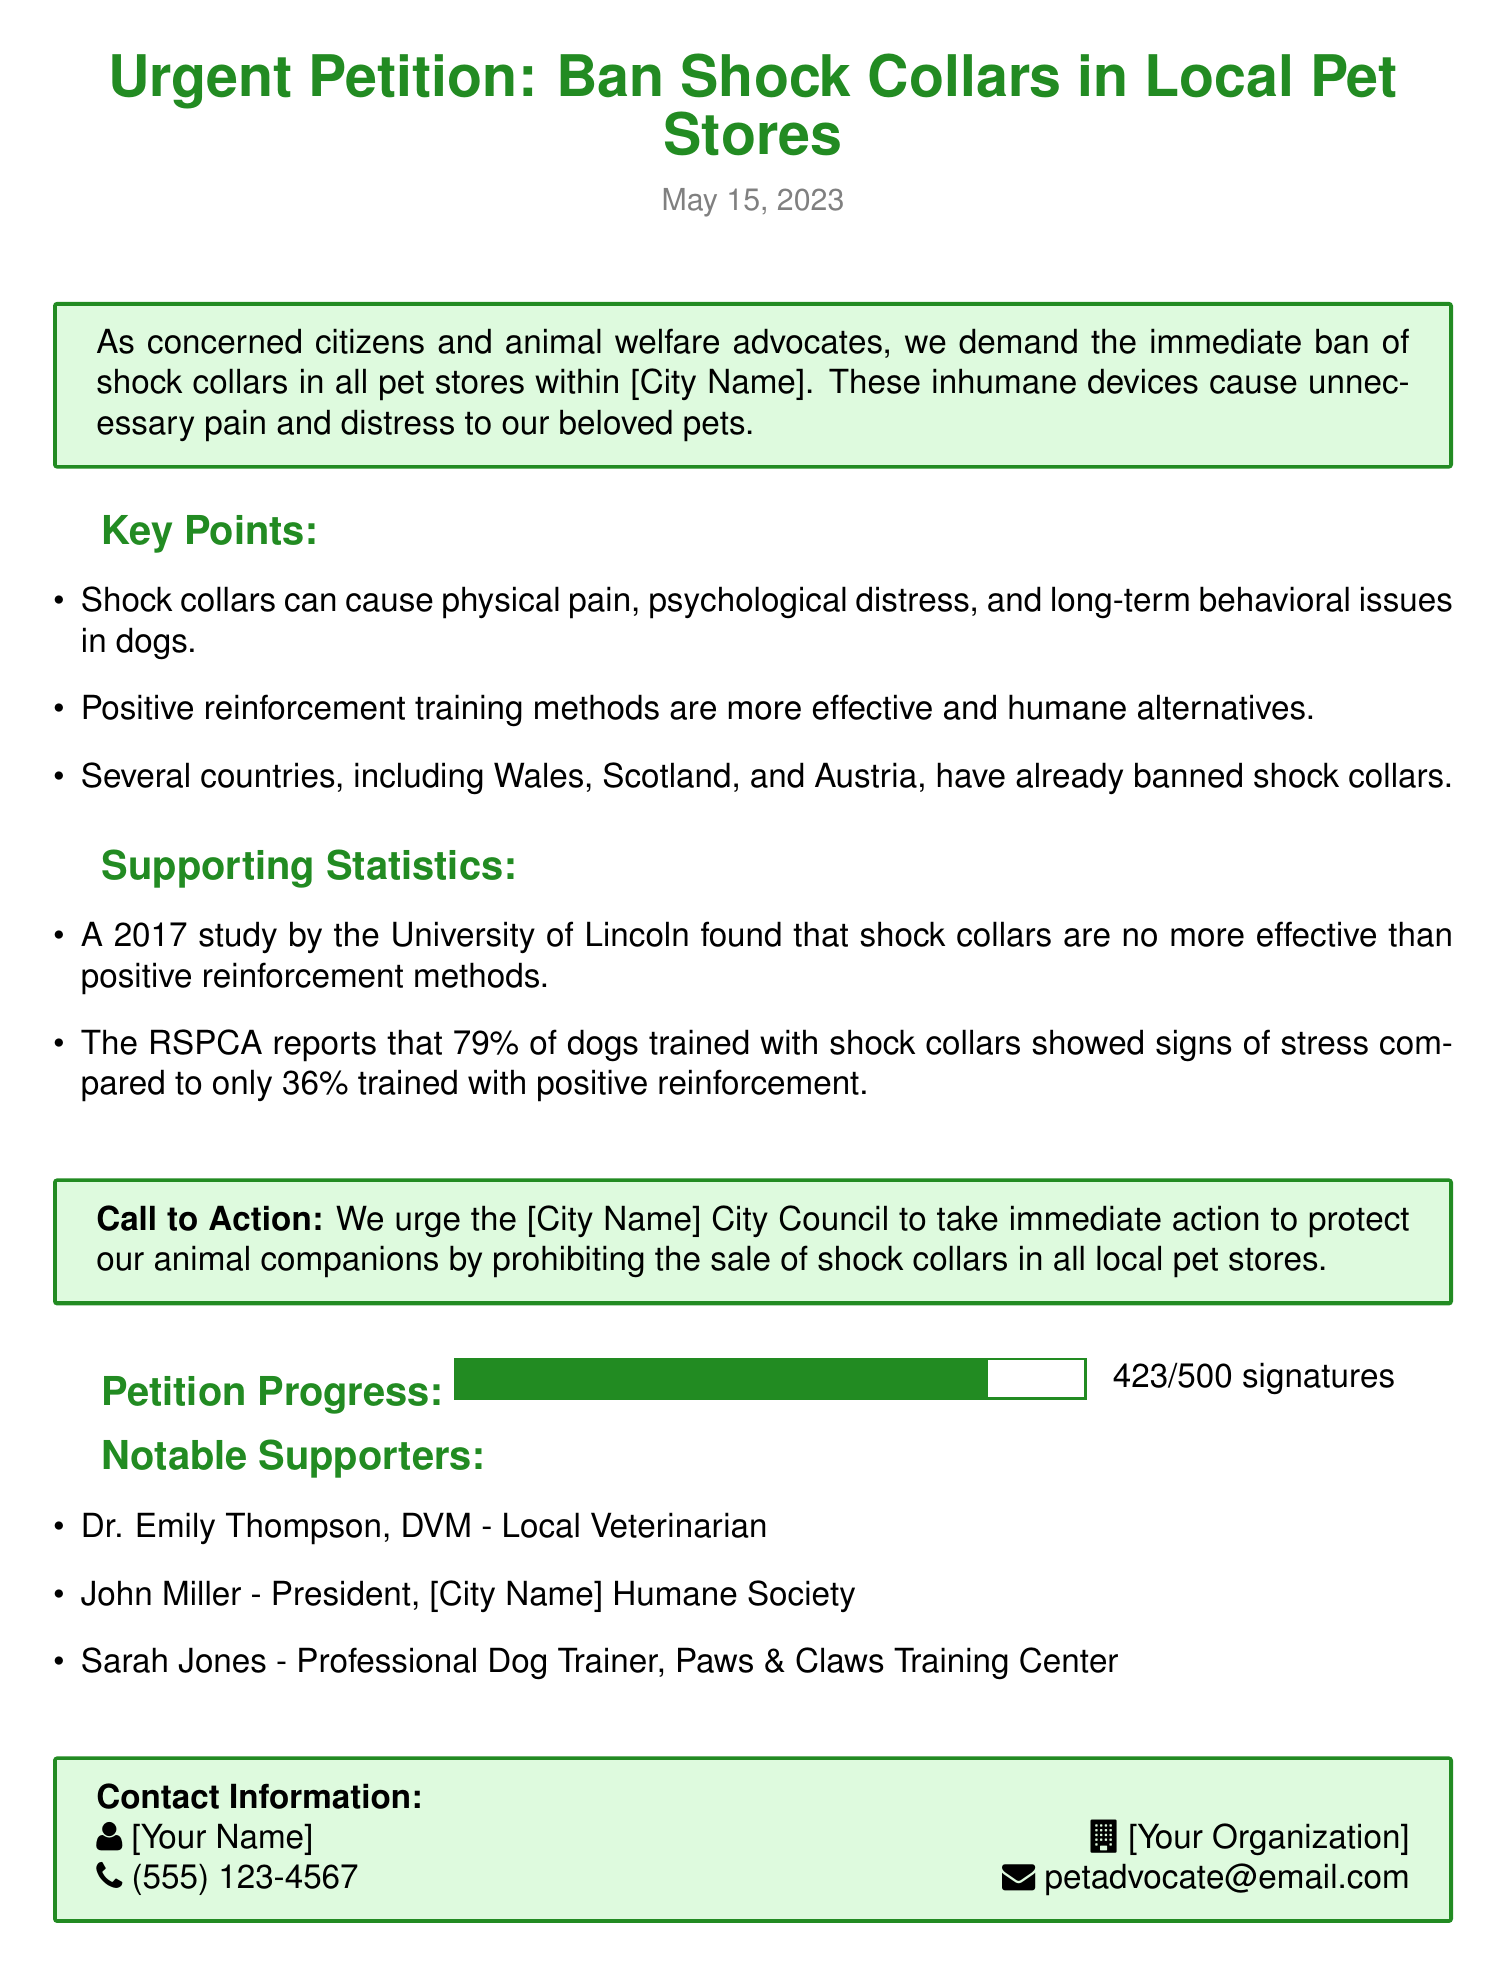What is the date of the petition? The date is stated at the beginning of the document as May 15, 2023.
Answer: May 15, 2023 How many signatures have been collected so far? This information is displayed in the "Petition Progress" section, indicating the number of signatures.
Answer: 423 What percentage of dogs trained with shock collars showed signs of stress? The document provides statistics from the RSPCA about dogs trained with shock collars and their stress levels.
Answer: 79% Who is a notable supporter mentioned in the petition? The document lists several individuals as notable supporters of the petition.
Answer: Dr. Emily Thompson What is the main call to action in the petition? The "Call to Action" section summarizes the petition's urgent request to the city council.
Answer: Ban shock collars Which training method is suggested as an alternative to shock collars? The petition mentions a training method as a humane alternative to shock collars.
Answer: Positive reinforcement What are the three key points outlined in the petition? The petition lists three key issues regarding shock collars and their effects.
Answer: Physical pain, psychological distress, long-term behavioral issues What is the total number of signatures aimed for in the petition? The document states a goal for the number of signatures needed for the petition.
Answer: 500 